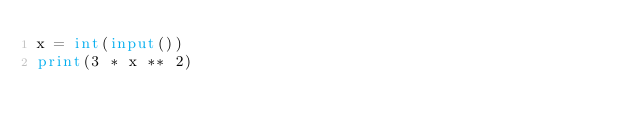Convert code to text. <code><loc_0><loc_0><loc_500><loc_500><_Python_>x = int(input())
print(3 * x ** 2)</code> 